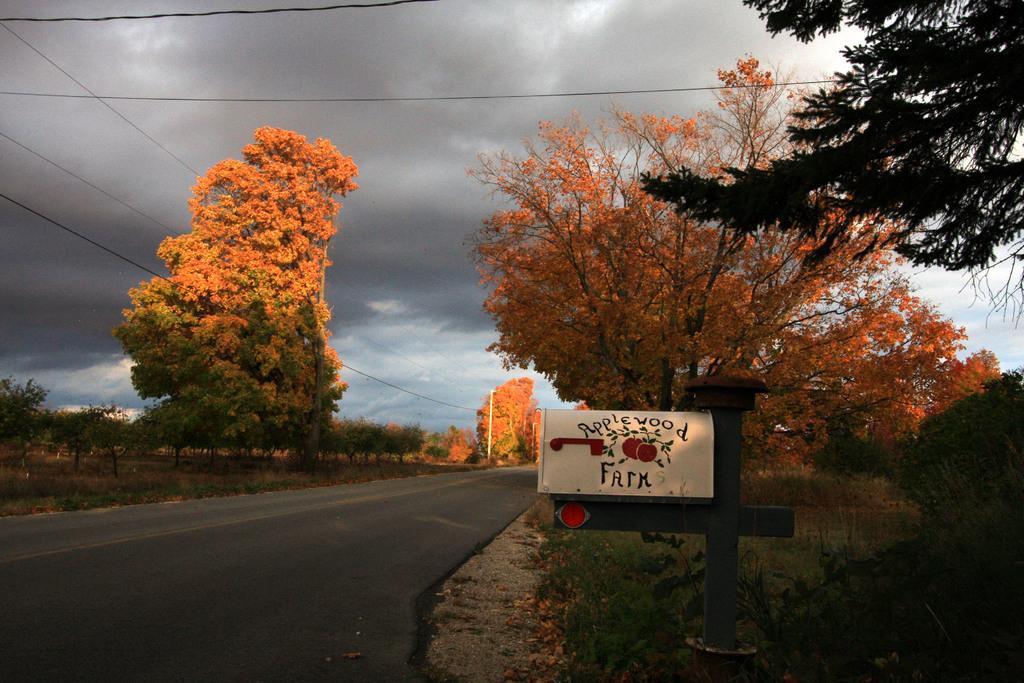In one or two sentences, can you explain what this image depicts? At the top we can see the sky and transmission wires. In this picture we can see the trees, green grass, plants and the road. On the right side of the picture we can see the information board and a pole. 